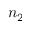Convert formula to latex. <formula><loc_0><loc_0><loc_500><loc_500>n _ { 2 }</formula> 